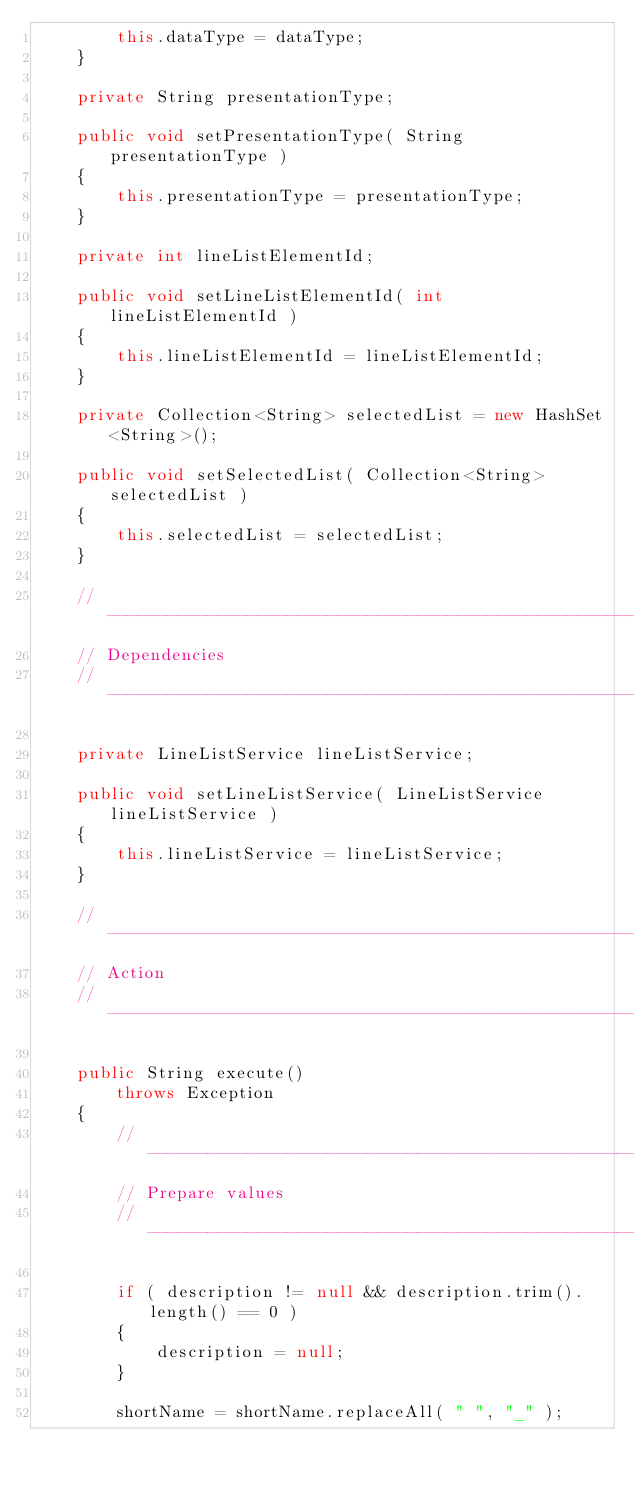<code> <loc_0><loc_0><loc_500><loc_500><_Java_>        this.dataType = dataType;
    }

    private String presentationType;

    public void setPresentationType( String presentationType )
    {
        this.presentationType = presentationType;
    }

    private int lineListElementId;

    public void setLineListElementId( int lineListElementId )
    {
        this.lineListElementId = lineListElementId;
    }

    private Collection<String> selectedList = new HashSet<String>();

    public void setSelectedList( Collection<String> selectedList )
    {
        this.selectedList = selectedList;
    }

    // -------------------------------------------------------------------------
    // Dependencies
    // -------------------------------------------------------------------------

    private LineListService lineListService;

    public void setLineListService( LineListService lineListService )
    {
        this.lineListService = lineListService;
    }

    // -------------------------------------------------------------------------
    // Action
    // -------------------------------------------------------------------------

    public String execute()
        throws Exception
    {
        // ---------------------------------------------------------------------
        // Prepare values
        // ---------------------------------------------------------------------

        if ( description != null && description.trim().length() == 0 )
        {
            description = null;
        }

        shortName = shortName.replaceAll( " ", "_" );</code> 